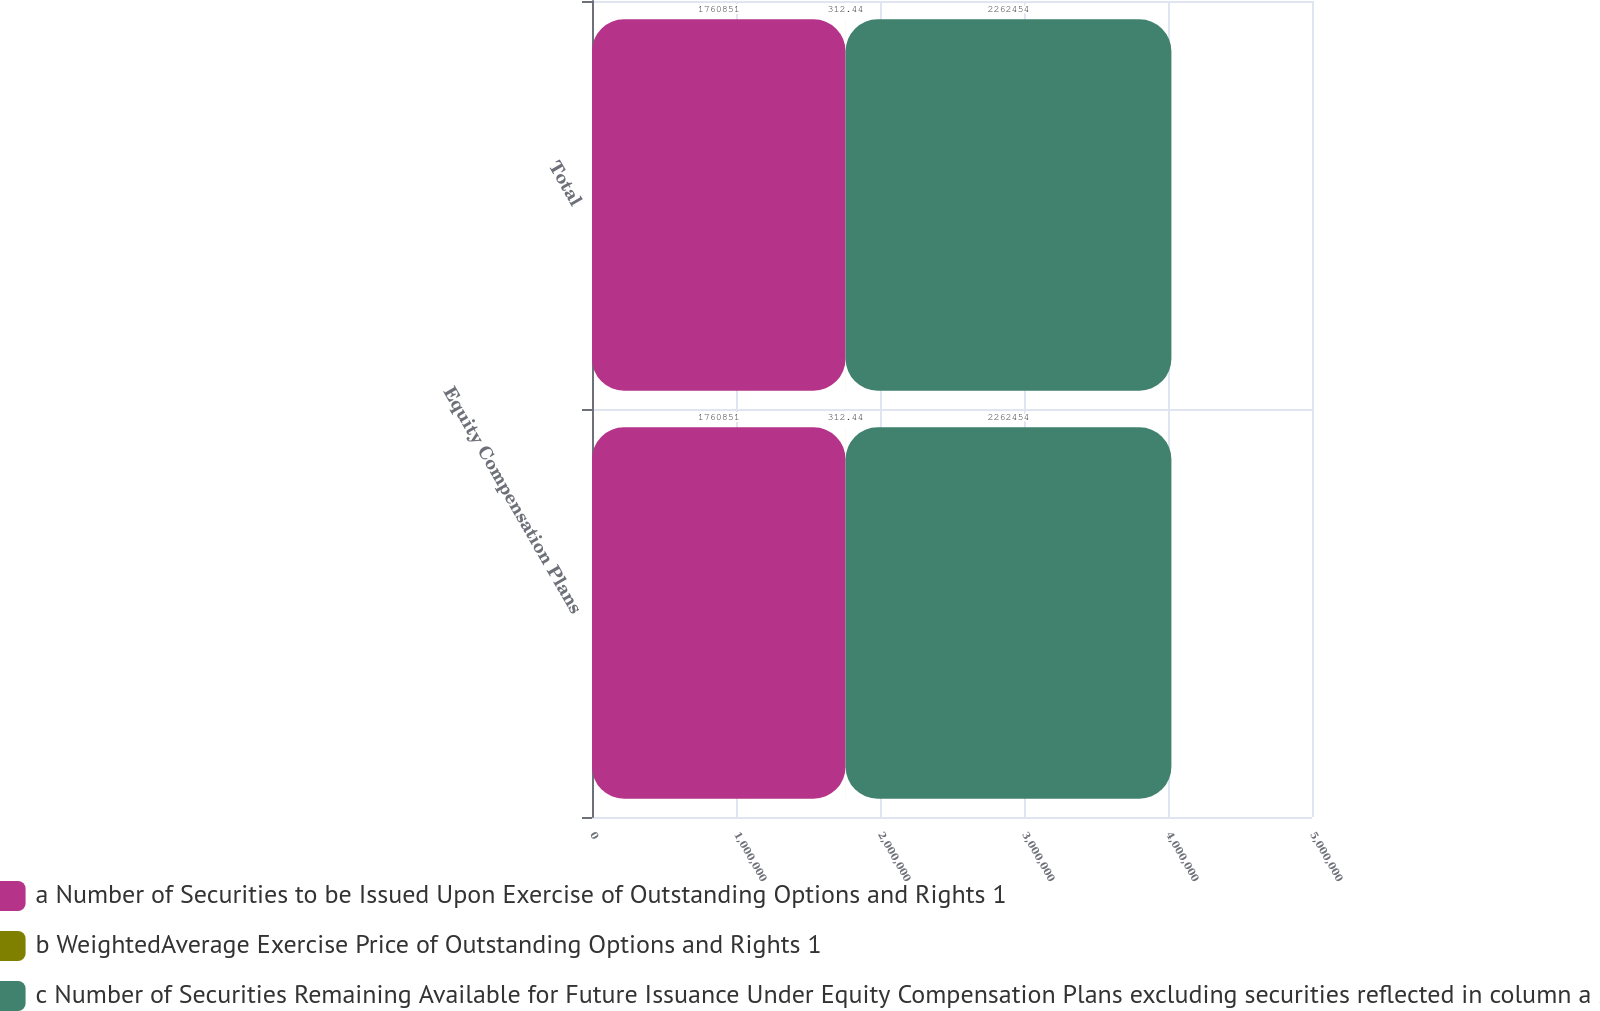<chart> <loc_0><loc_0><loc_500><loc_500><stacked_bar_chart><ecel><fcel>Equity Compensation Plans<fcel>Total<nl><fcel>a Number of Securities to be Issued Upon Exercise of Outstanding Options and Rights 1<fcel>1.76085e+06<fcel>1.76085e+06<nl><fcel>b WeightedAverage Exercise Price of Outstanding Options and Rights 1<fcel>312.44<fcel>312.44<nl><fcel>c Number of Securities Remaining Available for Future Issuance Under Equity Compensation Plans excluding securities reflected in column a 2<fcel>2.26245e+06<fcel>2.26245e+06<nl></chart> 